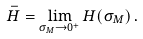<formula> <loc_0><loc_0><loc_500><loc_500>\bar { H } = \lim _ { \sigma _ { M } \rightarrow 0 ^ { + } } H ( \sigma _ { M } ) \, .</formula> 